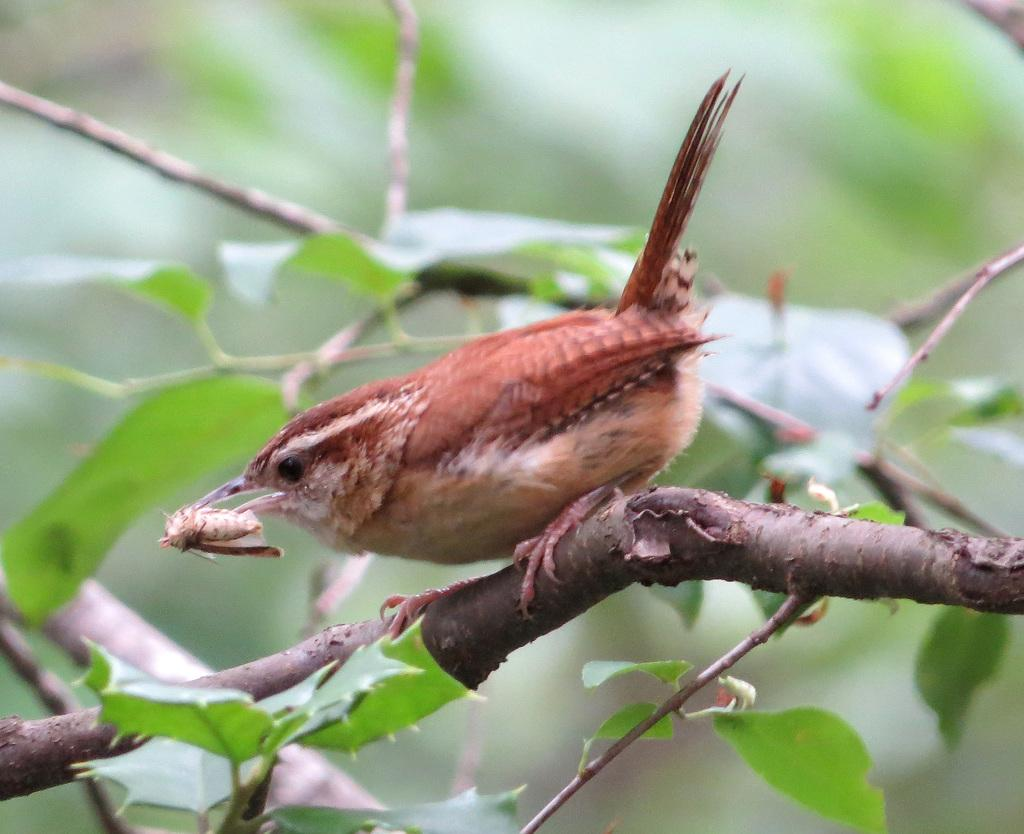What type of animal can be seen in the image? There is a bird in the image. Where is the bird located? The bird is on a tree branch. What is the bird holding or carrying in its mouth? There is an object in the bird's mouth. What type of coil is visible in the bird's nest in the image? There is no coil or nest visible in the image; it only shows a bird on a tree branch with an object in its mouth. 